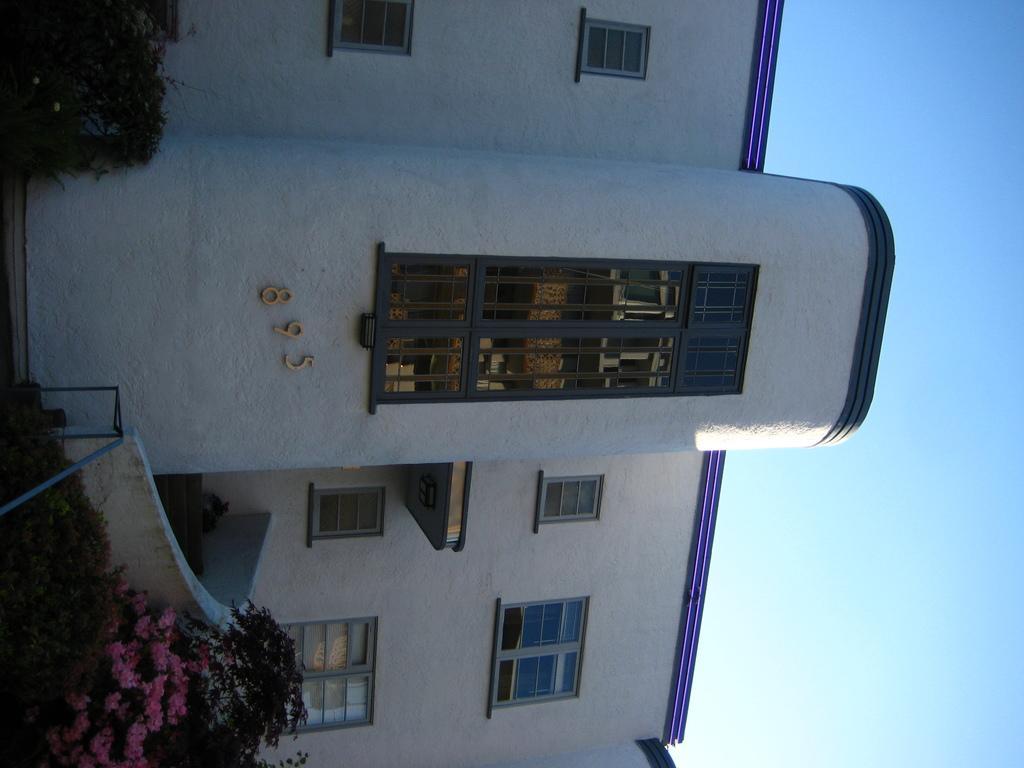Could you give a brief overview of what you see in this image? In this image there is a building and there are numbers written on the wall of the building and in front of the building there are plants and flowers. 